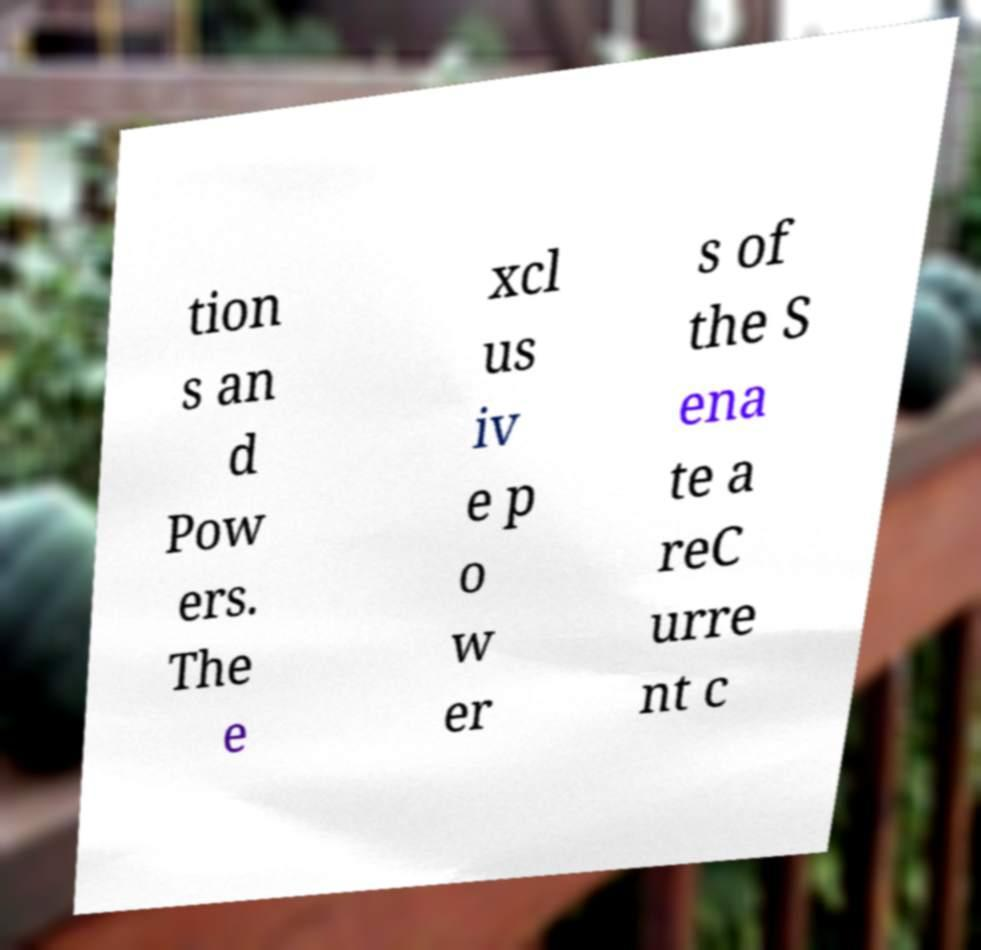What messages or text are displayed in this image? I need them in a readable, typed format. tion s an d Pow ers. The e xcl us iv e p o w er s of the S ena te a reC urre nt c 